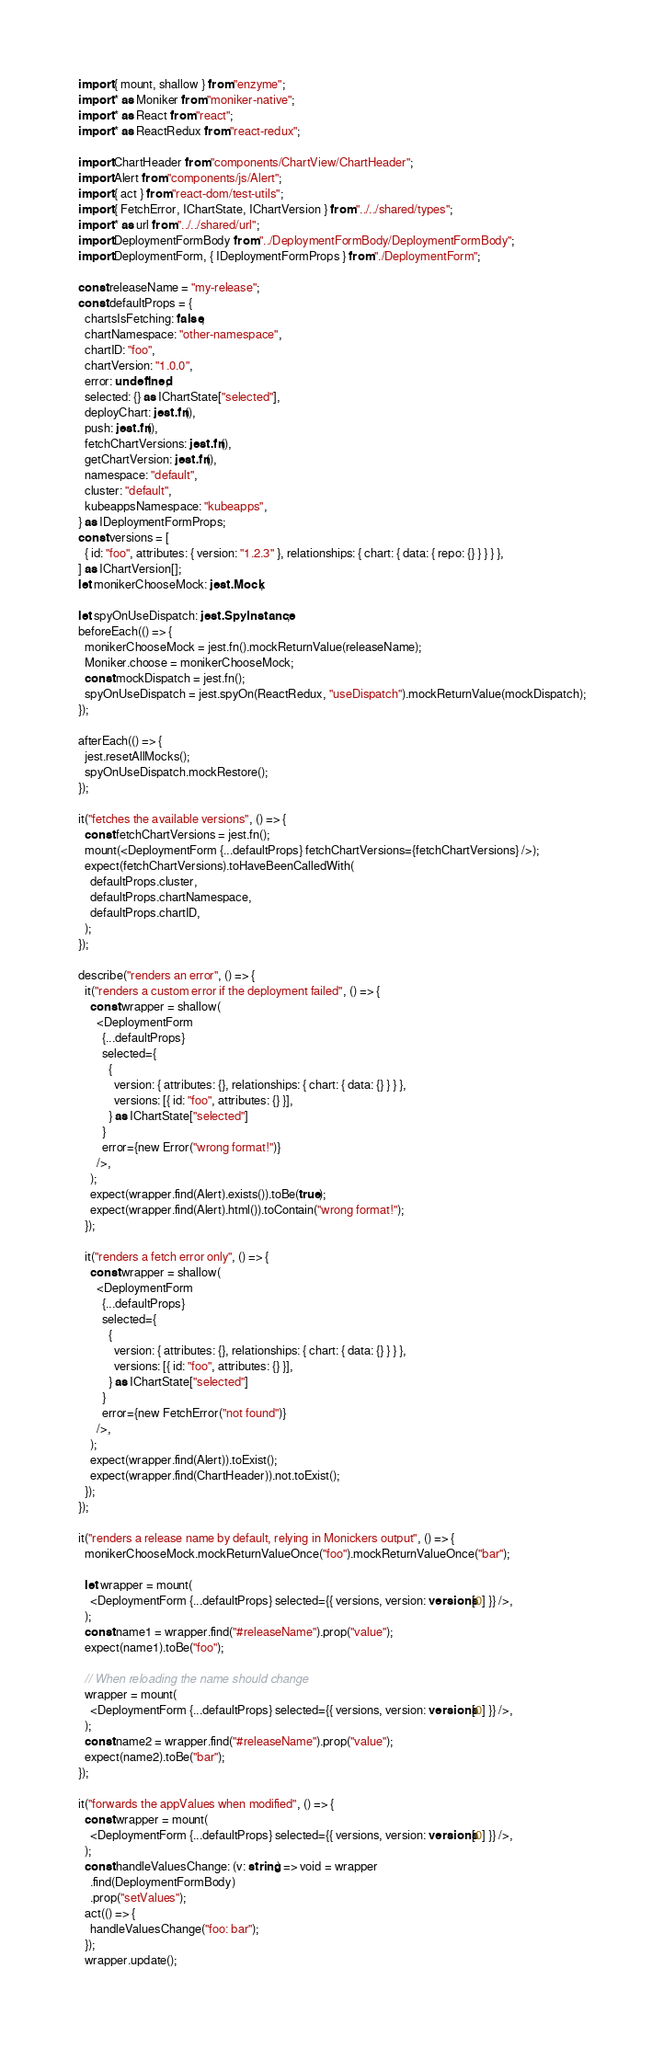Convert code to text. <code><loc_0><loc_0><loc_500><loc_500><_TypeScript_>import { mount, shallow } from "enzyme";
import * as Moniker from "moniker-native";
import * as React from "react";
import * as ReactRedux from "react-redux";

import ChartHeader from "components/ChartView/ChartHeader";
import Alert from "components/js/Alert";
import { act } from "react-dom/test-utils";
import { FetchError, IChartState, IChartVersion } from "../../shared/types";
import * as url from "../../shared/url";
import DeploymentFormBody from "../DeploymentFormBody/DeploymentFormBody";
import DeploymentForm, { IDeploymentFormProps } from "./DeploymentForm";

const releaseName = "my-release";
const defaultProps = {
  chartsIsFetching: false,
  chartNamespace: "other-namespace",
  chartID: "foo",
  chartVersion: "1.0.0",
  error: undefined,
  selected: {} as IChartState["selected"],
  deployChart: jest.fn(),
  push: jest.fn(),
  fetchChartVersions: jest.fn(),
  getChartVersion: jest.fn(),
  namespace: "default",
  cluster: "default",
  kubeappsNamespace: "kubeapps",
} as IDeploymentFormProps;
const versions = [
  { id: "foo", attributes: { version: "1.2.3" }, relationships: { chart: { data: { repo: {} } } } },
] as IChartVersion[];
let monikerChooseMock: jest.Mock;

let spyOnUseDispatch: jest.SpyInstance;
beforeEach(() => {
  monikerChooseMock = jest.fn().mockReturnValue(releaseName);
  Moniker.choose = monikerChooseMock;
  const mockDispatch = jest.fn();
  spyOnUseDispatch = jest.spyOn(ReactRedux, "useDispatch").mockReturnValue(mockDispatch);
});

afterEach(() => {
  jest.resetAllMocks();
  spyOnUseDispatch.mockRestore();
});

it("fetches the available versions", () => {
  const fetchChartVersions = jest.fn();
  mount(<DeploymentForm {...defaultProps} fetchChartVersions={fetchChartVersions} />);
  expect(fetchChartVersions).toHaveBeenCalledWith(
    defaultProps.cluster,
    defaultProps.chartNamespace,
    defaultProps.chartID,
  );
});

describe("renders an error", () => {
  it("renders a custom error if the deployment failed", () => {
    const wrapper = shallow(
      <DeploymentForm
        {...defaultProps}
        selected={
          {
            version: { attributes: {}, relationships: { chart: { data: {} } } },
            versions: [{ id: "foo", attributes: {} }],
          } as IChartState["selected"]
        }
        error={new Error("wrong format!")}
      />,
    );
    expect(wrapper.find(Alert).exists()).toBe(true);
    expect(wrapper.find(Alert).html()).toContain("wrong format!");
  });

  it("renders a fetch error only", () => {
    const wrapper = shallow(
      <DeploymentForm
        {...defaultProps}
        selected={
          {
            version: { attributes: {}, relationships: { chart: { data: {} } } },
            versions: [{ id: "foo", attributes: {} }],
          } as IChartState["selected"]
        }
        error={new FetchError("not found")}
      />,
    );
    expect(wrapper.find(Alert)).toExist();
    expect(wrapper.find(ChartHeader)).not.toExist();
  });
});

it("renders a release name by default, relying in Monickers output", () => {
  monikerChooseMock.mockReturnValueOnce("foo").mockReturnValueOnce("bar");

  let wrapper = mount(
    <DeploymentForm {...defaultProps} selected={{ versions, version: versions[0] }} />,
  );
  const name1 = wrapper.find("#releaseName").prop("value");
  expect(name1).toBe("foo");

  // When reloading the name should change
  wrapper = mount(
    <DeploymentForm {...defaultProps} selected={{ versions, version: versions[0] }} />,
  );
  const name2 = wrapper.find("#releaseName").prop("value");
  expect(name2).toBe("bar");
});

it("forwards the appValues when modified", () => {
  const wrapper = mount(
    <DeploymentForm {...defaultProps} selected={{ versions, version: versions[0] }} />,
  );
  const handleValuesChange: (v: string) => void = wrapper
    .find(DeploymentFormBody)
    .prop("setValues");
  act(() => {
    handleValuesChange("foo: bar");
  });
  wrapper.update();</code> 